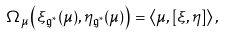<formula> <loc_0><loc_0><loc_500><loc_500>\Omega _ { \mu } \left ( \xi _ { \mathfrak { g } ^ { \ast } } ( \mu ) , \eta _ { \mathfrak { g } ^ { \ast } } ( \mu ) \right ) = \left \langle \mu , [ \xi , \eta ] \right \rangle ,</formula> 